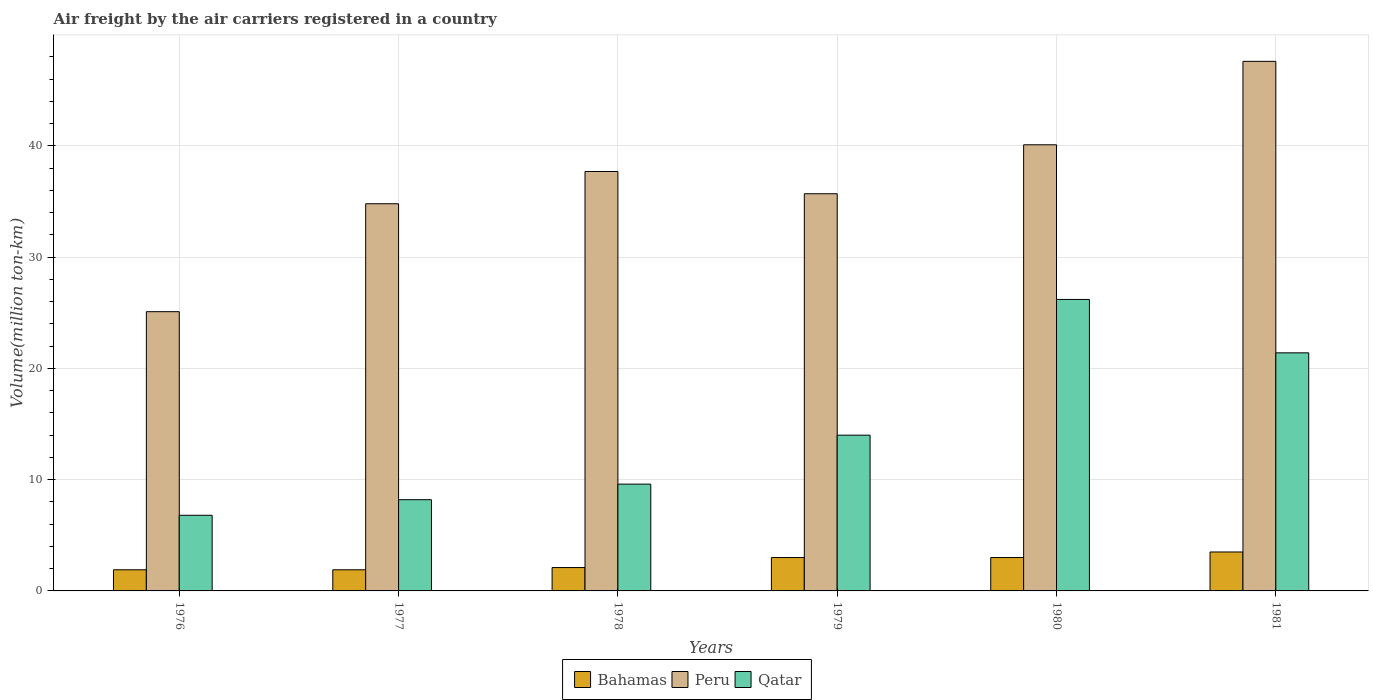How many groups of bars are there?
Your answer should be compact. 6. How many bars are there on the 5th tick from the right?
Offer a very short reply. 3. What is the volume of the air carriers in Peru in 1979?
Your answer should be compact. 35.7. Across all years, what is the maximum volume of the air carriers in Qatar?
Provide a succinct answer. 26.2. Across all years, what is the minimum volume of the air carriers in Peru?
Give a very brief answer. 25.1. In which year was the volume of the air carriers in Peru maximum?
Ensure brevity in your answer.  1981. In which year was the volume of the air carriers in Qatar minimum?
Provide a short and direct response. 1976. What is the total volume of the air carriers in Qatar in the graph?
Your response must be concise. 86.2. What is the difference between the volume of the air carriers in Bahamas in 1977 and that in 1981?
Your response must be concise. -1.6. What is the difference between the volume of the air carriers in Bahamas in 1981 and the volume of the air carriers in Qatar in 1977?
Your response must be concise. -4.7. What is the average volume of the air carriers in Bahamas per year?
Provide a succinct answer. 2.57. In the year 1979, what is the difference between the volume of the air carriers in Qatar and volume of the air carriers in Peru?
Make the answer very short. -21.7. What is the ratio of the volume of the air carriers in Bahamas in 1978 to that in 1980?
Offer a very short reply. 0.7. Is the difference between the volume of the air carriers in Qatar in 1979 and 1980 greater than the difference between the volume of the air carriers in Peru in 1979 and 1980?
Ensure brevity in your answer.  No. What is the difference between the highest and the lowest volume of the air carriers in Qatar?
Your answer should be very brief. 19.4. In how many years, is the volume of the air carriers in Bahamas greater than the average volume of the air carriers in Bahamas taken over all years?
Your response must be concise. 3. Is the sum of the volume of the air carriers in Qatar in 1977 and 1980 greater than the maximum volume of the air carriers in Bahamas across all years?
Offer a very short reply. Yes. What does the 3rd bar from the left in 1978 represents?
Ensure brevity in your answer.  Qatar. What does the 1st bar from the right in 1978 represents?
Your response must be concise. Qatar. What is the difference between two consecutive major ticks on the Y-axis?
Offer a terse response. 10. Are the values on the major ticks of Y-axis written in scientific E-notation?
Make the answer very short. No. Does the graph contain any zero values?
Provide a succinct answer. No. Does the graph contain grids?
Give a very brief answer. Yes. How many legend labels are there?
Provide a short and direct response. 3. How are the legend labels stacked?
Provide a short and direct response. Horizontal. What is the title of the graph?
Your answer should be compact. Air freight by the air carriers registered in a country. Does "Korea (Democratic)" appear as one of the legend labels in the graph?
Your answer should be compact. No. What is the label or title of the Y-axis?
Provide a short and direct response. Volume(million ton-km). What is the Volume(million ton-km) in Bahamas in 1976?
Keep it short and to the point. 1.9. What is the Volume(million ton-km) of Peru in 1976?
Provide a short and direct response. 25.1. What is the Volume(million ton-km) in Qatar in 1976?
Your answer should be compact. 6.8. What is the Volume(million ton-km) of Bahamas in 1977?
Give a very brief answer. 1.9. What is the Volume(million ton-km) in Peru in 1977?
Provide a succinct answer. 34.8. What is the Volume(million ton-km) in Qatar in 1977?
Your answer should be very brief. 8.2. What is the Volume(million ton-km) of Bahamas in 1978?
Offer a very short reply. 2.1. What is the Volume(million ton-km) in Peru in 1978?
Provide a succinct answer. 37.7. What is the Volume(million ton-km) in Qatar in 1978?
Give a very brief answer. 9.6. What is the Volume(million ton-km) in Peru in 1979?
Your response must be concise. 35.7. What is the Volume(million ton-km) in Qatar in 1979?
Your response must be concise. 14. What is the Volume(million ton-km) of Peru in 1980?
Offer a very short reply. 40.1. What is the Volume(million ton-km) in Qatar in 1980?
Provide a succinct answer. 26.2. What is the Volume(million ton-km) in Peru in 1981?
Give a very brief answer. 47.6. What is the Volume(million ton-km) in Qatar in 1981?
Your answer should be compact. 21.4. Across all years, what is the maximum Volume(million ton-km) of Bahamas?
Make the answer very short. 3.5. Across all years, what is the maximum Volume(million ton-km) in Peru?
Ensure brevity in your answer.  47.6. Across all years, what is the maximum Volume(million ton-km) in Qatar?
Provide a succinct answer. 26.2. Across all years, what is the minimum Volume(million ton-km) in Bahamas?
Give a very brief answer. 1.9. Across all years, what is the minimum Volume(million ton-km) of Peru?
Keep it short and to the point. 25.1. Across all years, what is the minimum Volume(million ton-km) of Qatar?
Keep it short and to the point. 6.8. What is the total Volume(million ton-km) in Bahamas in the graph?
Give a very brief answer. 15.4. What is the total Volume(million ton-km) in Peru in the graph?
Offer a terse response. 221. What is the total Volume(million ton-km) in Qatar in the graph?
Provide a short and direct response. 86.2. What is the difference between the Volume(million ton-km) of Peru in 1976 and that in 1977?
Give a very brief answer. -9.7. What is the difference between the Volume(million ton-km) of Qatar in 1976 and that in 1977?
Keep it short and to the point. -1.4. What is the difference between the Volume(million ton-km) of Bahamas in 1976 and that in 1978?
Keep it short and to the point. -0.2. What is the difference between the Volume(million ton-km) of Qatar in 1976 and that in 1978?
Give a very brief answer. -2.8. What is the difference between the Volume(million ton-km) in Bahamas in 1976 and that in 1980?
Your response must be concise. -1.1. What is the difference between the Volume(million ton-km) of Qatar in 1976 and that in 1980?
Provide a short and direct response. -19.4. What is the difference between the Volume(million ton-km) in Peru in 1976 and that in 1981?
Make the answer very short. -22.5. What is the difference between the Volume(million ton-km) in Qatar in 1976 and that in 1981?
Provide a succinct answer. -14.6. What is the difference between the Volume(million ton-km) of Bahamas in 1977 and that in 1978?
Give a very brief answer. -0.2. What is the difference between the Volume(million ton-km) of Qatar in 1977 and that in 1978?
Keep it short and to the point. -1.4. What is the difference between the Volume(million ton-km) in Peru in 1977 and that in 1979?
Make the answer very short. -0.9. What is the difference between the Volume(million ton-km) of Qatar in 1977 and that in 1979?
Your response must be concise. -5.8. What is the difference between the Volume(million ton-km) of Peru in 1977 and that in 1980?
Your response must be concise. -5.3. What is the difference between the Volume(million ton-km) of Bahamas in 1977 and that in 1981?
Your answer should be very brief. -1.6. What is the difference between the Volume(million ton-km) of Peru in 1977 and that in 1981?
Provide a short and direct response. -12.8. What is the difference between the Volume(million ton-km) in Bahamas in 1978 and that in 1979?
Your response must be concise. -0.9. What is the difference between the Volume(million ton-km) of Peru in 1978 and that in 1979?
Make the answer very short. 2. What is the difference between the Volume(million ton-km) in Bahamas in 1978 and that in 1980?
Your answer should be compact. -0.9. What is the difference between the Volume(million ton-km) of Peru in 1978 and that in 1980?
Give a very brief answer. -2.4. What is the difference between the Volume(million ton-km) of Qatar in 1978 and that in 1980?
Your response must be concise. -16.6. What is the difference between the Volume(million ton-km) of Peru in 1979 and that in 1980?
Give a very brief answer. -4.4. What is the difference between the Volume(million ton-km) in Peru in 1979 and that in 1981?
Keep it short and to the point. -11.9. What is the difference between the Volume(million ton-km) of Bahamas in 1980 and that in 1981?
Make the answer very short. -0.5. What is the difference between the Volume(million ton-km) in Qatar in 1980 and that in 1981?
Ensure brevity in your answer.  4.8. What is the difference between the Volume(million ton-km) in Bahamas in 1976 and the Volume(million ton-km) in Peru in 1977?
Provide a short and direct response. -32.9. What is the difference between the Volume(million ton-km) of Bahamas in 1976 and the Volume(million ton-km) of Qatar in 1977?
Make the answer very short. -6.3. What is the difference between the Volume(million ton-km) in Peru in 1976 and the Volume(million ton-km) in Qatar in 1977?
Offer a very short reply. 16.9. What is the difference between the Volume(million ton-km) in Bahamas in 1976 and the Volume(million ton-km) in Peru in 1978?
Offer a very short reply. -35.8. What is the difference between the Volume(million ton-km) in Bahamas in 1976 and the Volume(million ton-km) in Qatar in 1978?
Provide a short and direct response. -7.7. What is the difference between the Volume(million ton-km) of Peru in 1976 and the Volume(million ton-km) of Qatar in 1978?
Provide a succinct answer. 15.5. What is the difference between the Volume(million ton-km) in Bahamas in 1976 and the Volume(million ton-km) in Peru in 1979?
Your response must be concise. -33.8. What is the difference between the Volume(million ton-km) in Bahamas in 1976 and the Volume(million ton-km) in Peru in 1980?
Ensure brevity in your answer.  -38.2. What is the difference between the Volume(million ton-km) of Bahamas in 1976 and the Volume(million ton-km) of Qatar in 1980?
Your answer should be compact. -24.3. What is the difference between the Volume(million ton-km) in Bahamas in 1976 and the Volume(million ton-km) in Peru in 1981?
Your answer should be very brief. -45.7. What is the difference between the Volume(million ton-km) of Bahamas in 1976 and the Volume(million ton-km) of Qatar in 1981?
Your answer should be very brief. -19.5. What is the difference between the Volume(million ton-km) in Peru in 1976 and the Volume(million ton-km) in Qatar in 1981?
Provide a succinct answer. 3.7. What is the difference between the Volume(million ton-km) in Bahamas in 1977 and the Volume(million ton-km) in Peru in 1978?
Give a very brief answer. -35.8. What is the difference between the Volume(million ton-km) of Peru in 1977 and the Volume(million ton-km) of Qatar in 1978?
Provide a short and direct response. 25.2. What is the difference between the Volume(million ton-km) in Bahamas in 1977 and the Volume(million ton-km) in Peru in 1979?
Keep it short and to the point. -33.8. What is the difference between the Volume(million ton-km) in Peru in 1977 and the Volume(million ton-km) in Qatar in 1979?
Your answer should be very brief. 20.8. What is the difference between the Volume(million ton-km) in Bahamas in 1977 and the Volume(million ton-km) in Peru in 1980?
Your response must be concise. -38.2. What is the difference between the Volume(million ton-km) in Bahamas in 1977 and the Volume(million ton-km) in Qatar in 1980?
Give a very brief answer. -24.3. What is the difference between the Volume(million ton-km) in Peru in 1977 and the Volume(million ton-km) in Qatar in 1980?
Your answer should be compact. 8.6. What is the difference between the Volume(million ton-km) of Bahamas in 1977 and the Volume(million ton-km) of Peru in 1981?
Provide a short and direct response. -45.7. What is the difference between the Volume(million ton-km) in Bahamas in 1977 and the Volume(million ton-km) in Qatar in 1981?
Provide a succinct answer. -19.5. What is the difference between the Volume(million ton-km) of Peru in 1977 and the Volume(million ton-km) of Qatar in 1981?
Provide a succinct answer. 13.4. What is the difference between the Volume(million ton-km) of Bahamas in 1978 and the Volume(million ton-km) of Peru in 1979?
Make the answer very short. -33.6. What is the difference between the Volume(million ton-km) of Peru in 1978 and the Volume(million ton-km) of Qatar in 1979?
Make the answer very short. 23.7. What is the difference between the Volume(million ton-km) in Bahamas in 1978 and the Volume(million ton-km) in Peru in 1980?
Keep it short and to the point. -38. What is the difference between the Volume(million ton-km) in Bahamas in 1978 and the Volume(million ton-km) in Qatar in 1980?
Keep it short and to the point. -24.1. What is the difference between the Volume(million ton-km) in Bahamas in 1978 and the Volume(million ton-km) in Peru in 1981?
Keep it short and to the point. -45.5. What is the difference between the Volume(million ton-km) in Bahamas in 1978 and the Volume(million ton-km) in Qatar in 1981?
Provide a short and direct response. -19.3. What is the difference between the Volume(million ton-km) of Peru in 1978 and the Volume(million ton-km) of Qatar in 1981?
Ensure brevity in your answer.  16.3. What is the difference between the Volume(million ton-km) in Bahamas in 1979 and the Volume(million ton-km) in Peru in 1980?
Provide a short and direct response. -37.1. What is the difference between the Volume(million ton-km) of Bahamas in 1979 and the Volume(million ton-km) of Qatar in 1980?
Keep it short and to the point. -23.2. What is the difference between the Volume(million ton-km) of Bahamas in 1979 and the Volume(million ton-km) of Peru in 1981?
Provide a succinct answer. -44.6. What is the difference between the Volume(million ton-km) in Bahamas in 1979 and the Volume(million ton-km) in Qatar in 1981?
Ensure brevity in your answer.  -18.4. What is the difference between the Volume(million ton-km) in Bahamas in 1980 and the Volume(million ton-km) in Peru in 1981?
Provide a succinct answer. -44.6. What is the difference between the Volume(million ton-km) of Bahamas in 1980 and the Volume(million ton-km) of Qatar in 1981?
Offer a very short reply. -18.4. What is the average Volume(million ton-km) of Bahamas per year?
Keep it short and to the point. 2.57. What is the average Volume(million ton-km) in Peru per year?
Provide a succinct answer. 36.83. What is the average Volume(million ton-km) of Qatar per year?
Provide a succinct answer. 14.37. In the year 1976, what is the difference between the Volume(million ton-km) of Bahamas and Volume(million ton-km) of Peru?
Your response must be concise. -23.2. In the year 1976, what is the difference between the Volume(million ton-km) in Bahamas and Volume(million ton-km) in Qatar?
Ensure brevity in your answer.  -4.9. In the year 1976, what is the difference between the Volume(million ton-km) of Peru and Volume(million ton-km) of Qatar?
Make the answer very short. 18.3. In the year 1977, what is the difference between the Volume(million ton-km) of Bahamas and Volume(million ton-km) of Peru?
Your response must be concise. -32.9. In the year 1977, what is the difference between the Volume(million ton-km) of Peru and Volume(million ton-km) of Qatar?
Provide a succinct answer. 26.6. In the year 1978, what is the difference between the Volume(million ton-km) of Bahamas and Volume(million ton-km) of Peru?
Provide a short and direct response. -35.6. In the year 1978, what is the difference between the Volume(million ton-km) of Bahamas and Volume(million ton-km) of Qatar?
Offer a terse response. -7.5. In the year 1978, what is the difference between the Volume(million ton-km) in Peru and Volume(million ton-km) in Qatar?
Your answer should be compact. 28.1. In the year 1979, what is the difference between the Volume(million ton-km) in Bahamas and Volume(million ton-km) in Peru?
Give a very brief answer. -32.7. In the year 1979, what is the difference between the Volume(million ton-km) of Peru and Volume(million ton-km) of Qatar?
Provide a short and direct response. 21.7. In the year 1980, what is the difference between the Volume(million ton-km) in Bahamas and Volume(million ton-km) in Peru?
Offer a very short reply. -37.1. In the year 1980, what is the difference between the Volume(million ton-km) of Bahamas and Volume(million ton-km) of Qatar?
Provide a succinct answer. -23.2. In the year 1980, what is the difference between the Volume(million ton-km) of Peru and Volume(million ton-km) of Qatar?
Offer a terse response. 13.9. In the year 1981, what is the difference between the Volume(million ton-km) of Bahamas and Volume(million ton-km) of Peru?
Ensure brevity in your answer.  -44.1. In the year 1981, what is the difference between the Volume(million ton-km) of Bahamas and Volume(million ton-km) of Qatar?
Offer a terse response. -17.9. In the year 1981, what is the difference between the Volume(million ton-km) of Peru and Volume(million ton-km) of Qatar?
Give a very brief answer. 26.2. What is the ratio of the Volume(million ton-km) of Peru in 1976 to that in 1977?
Provide a short and direct response. 0.72. What is the ratio of the Volume(million ton-km) of Qatar in 1976 to that in 1977?
Give a very brief answer. 0.83. What is the ratio of the Volume(million ton-km) in Bahamas in 1976 to that in 1978?
Ensure brevity in your answer.  0.9. What is the ratio of the Volume(million ton-km) in Peru in 1976 to that in 1978?
Keep it short and to the point. 0.67. What is the ratio of the Volume(million ton-km) in Qatar in 1976 to that in 1978?
Ensure brevity in your answer.  0.71. What is the ratio of the Volume(million ton-km) of Bahamas in 1976 to that in 1979?
Make the answer very short. 0.63. What is the ratio of the Volume(million ton-km) in Peru in 1976 to that in 1979?
Offer a terse response. 0.7. What is the ratio of the Volume(million ton-km) in Qatar in 1976 to that in 1979?
Your response must be concise. 0.49. What is the ratio of the Volume(million ton-km) in Bahamas in 1976 to that in 1980?
Your answer should be compact. 0.63. What is the ratio of the Volume(million ton-km) of Peru in 1976 to that in 1980?
Offer a terse response. 0.63. What is the ratio of the Volume(million ton-km) in Qatar in 1976 to that in 1980?
Ensure brevity in your answer.  0.26. What is the ratio of the Volume(million ton-km) of Bahamas in 1976 to that in 1981?
Provide a succinct answer. 0.54. What is the ratio of the Volume(million ton-km) of Peru in 1976 to that in 1981?
Your response must be concise. 0.53. What is the ratio of the Volume(million ton-km) of Qatar in 1976 to that in 1981?
Keep it short and to the point. 0.32. What is the ratio of the Volume(million ton-km) of Bahamas in 1977 to that in 1978?
Provide a short and direct response. 0.9. What is the ratio of the Volume(million ton-km) of Peru in 1977 to that in 1978?
Provide a short and direct response. 0.92. What is the ratio of the Volume(million ton-km) in Qatar in 1977 to that in 1978?
Make the answer very short. 0.85. What is the ratio of the Volume(million ton-km) of Bahamas in 1977 to that in 1979?
Your response must be concise. 0.63. What is the ratio of the Volume(million ton-km) of Peru in 1977 to that in 1979?
Ensure brevity in your answer.  0.97. What is the ratio of the Volume(million ton-km) of Qatar in 1977 to that in 1979?
Make the answer very short. 0.59. What is the ratio of the Volume(million ton-km) of Bahamas in 1977 to that in 1980?
Provide a short and direct response. 0.63. What is the ratio of the Volume(million ton-km) of Peru in 1977 to that in 1980?
Your answer should be compact. 0.87. What is the ratio of the Volume(million ton-km) of Qatar in 1977 to that in 1980?
Give a very brief answer. 0.31. What is the ratio of the Volume(million ton-km) in Bahamas in 1977 to that in 1981?
Give a very brief answer. 0.54. What is the ratio of the Volume(million ton-km) of Peru in 1977 to that in 1981?
Ensure brevity in your answer.  0.73. What is the ratio of the Volume(million ton-km) in Qatar in 1977 to that in 1981?
Provide a short and direct response. 0.38. What is the ratio of the Volume(million ton-km) in Peru in 1978 to that in 1979?
Provide a short and direct response. 1.06. What is the ratio of the Volume(million ton-km) of Qatar in 1978 to that in 1979?
Provide a short and direct response. 0.69. What is the ratio of the Volume(million ton-km) in Bahamas in 1978 to that in 1980?
Your answer should be compact. 0.7. What is the ratio of the Volume(million ton-km) of Peru in 1978 to that in 1980?
Provide a succinct answer. 0.94. What is the ratio of the Volume(million ton-km) of Qatar in 1978 to that in 1980?
Provide a succinct answer. 0.37. What is the ratio of the Volume(million ton-km) in Peru in 1978 to that in 1981?
Provide a succinct answer. 0.79. What is the ratio of the Volume(million ton-km) of Qatar in 1978 to that in 1981?
Ensure brevity in your answer.  0.45. What is the ratio of the Volume(million ton-km) in Peru in 1979 to that in 1980?
Provide a short and direct response. 0.89. What is the ratio of the Volume(million ton-km) in Qatar in 1979 to that in 1980?
Offer a very short reply. 0.53. What is the ratio of the Volume(million ton-km) in Peru in 1979 to that in 1981?
Your response must be concise. 0.75. What is the ratio of the Volume(million ton-km) of Qatar in 1979 to that in 1981?
Provide a short and direct response. 0.65. What is the ratio of the Volume(million ton-km) in Bahamas in 1980 to that in 1981?
Provide a succinct answer. 0.86. What is the ratio of the Volume(million ton-km) in Peru in 1980 to that in 1981?
Provide a short and direct response. 0.84. What is the ratio of the Volume(million ton-km) of Qatar in 1980 to that in 1981?
Offer a terse response. 1.22. What is the difference between the highest and the second highest Volume(million ton-km) of Bahamas?
Give a very brief answer. 0.5. What is the difference between the highest and the lowest Volume(million ton-km) in Bahamas?
Your answer should be compact. 1.6. What is the difference between the highest and the lowest Volume(million ton-km) in Peru?
Provide a succinct answer. 22.5. 